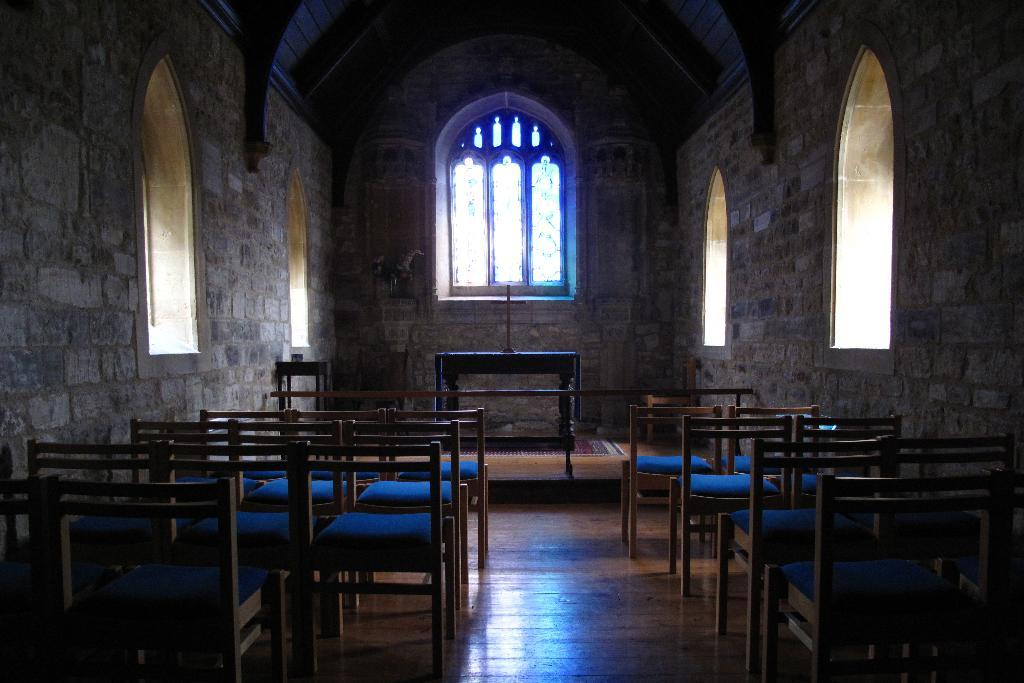What type of space is depicted in the image? The image shows the inside of a hall. Are there any sources of natural light in the hall? Yes, there are windows in the hall. How is the hall furnished? The hall has many chairs and a table. Can you describe the unspecified object in the hall? Unfortunately, the facts provided do not give any details about the unspecified object. How does the fog affect the visibility in the hall? There is no fog present in the image; it shows the inside of a hall with windows and furniture. What type of bird can be seen perched on the table in the image? There is no bird, specifically a wren, present in the image. 